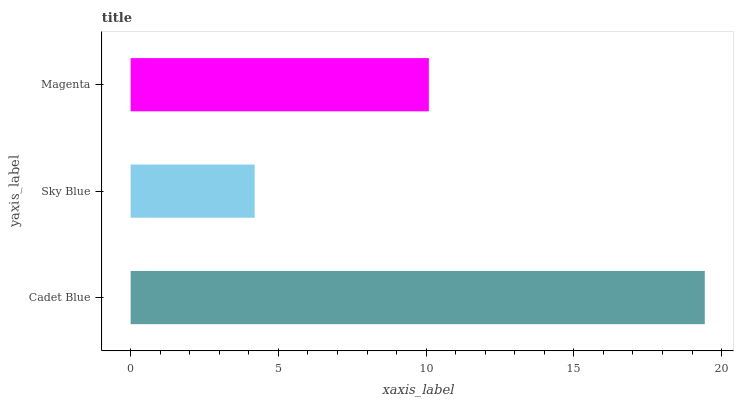Is Sky Blue the minimum?
Answer yes or no. Yes. Is Cadet Blue the maximum?
Answer yes or no. Yes. Is Magenta the minimum?
Answer yes or no. No. Is Magenta the maximum?
Answer yes or no. No. Is Magenta greater than Sky Blue?
Answer yes or no. Yes. Is Sky Blue less than Magenta?
Answer yes or no. Yes. Is Sky Blue greater than Magenta?
Answer yes or no. No. Is Magenta less than Sky Blue?
Answer yes or no. No. Is Magenta the high median?
Answer yes or no. Yes. Is Magenta the low median?
Answer yes or no. Yes. Is Sky Blue the high median?
Answer yes or no. No. Is Cadet Blue the low median?
Answer yes or no. No. 